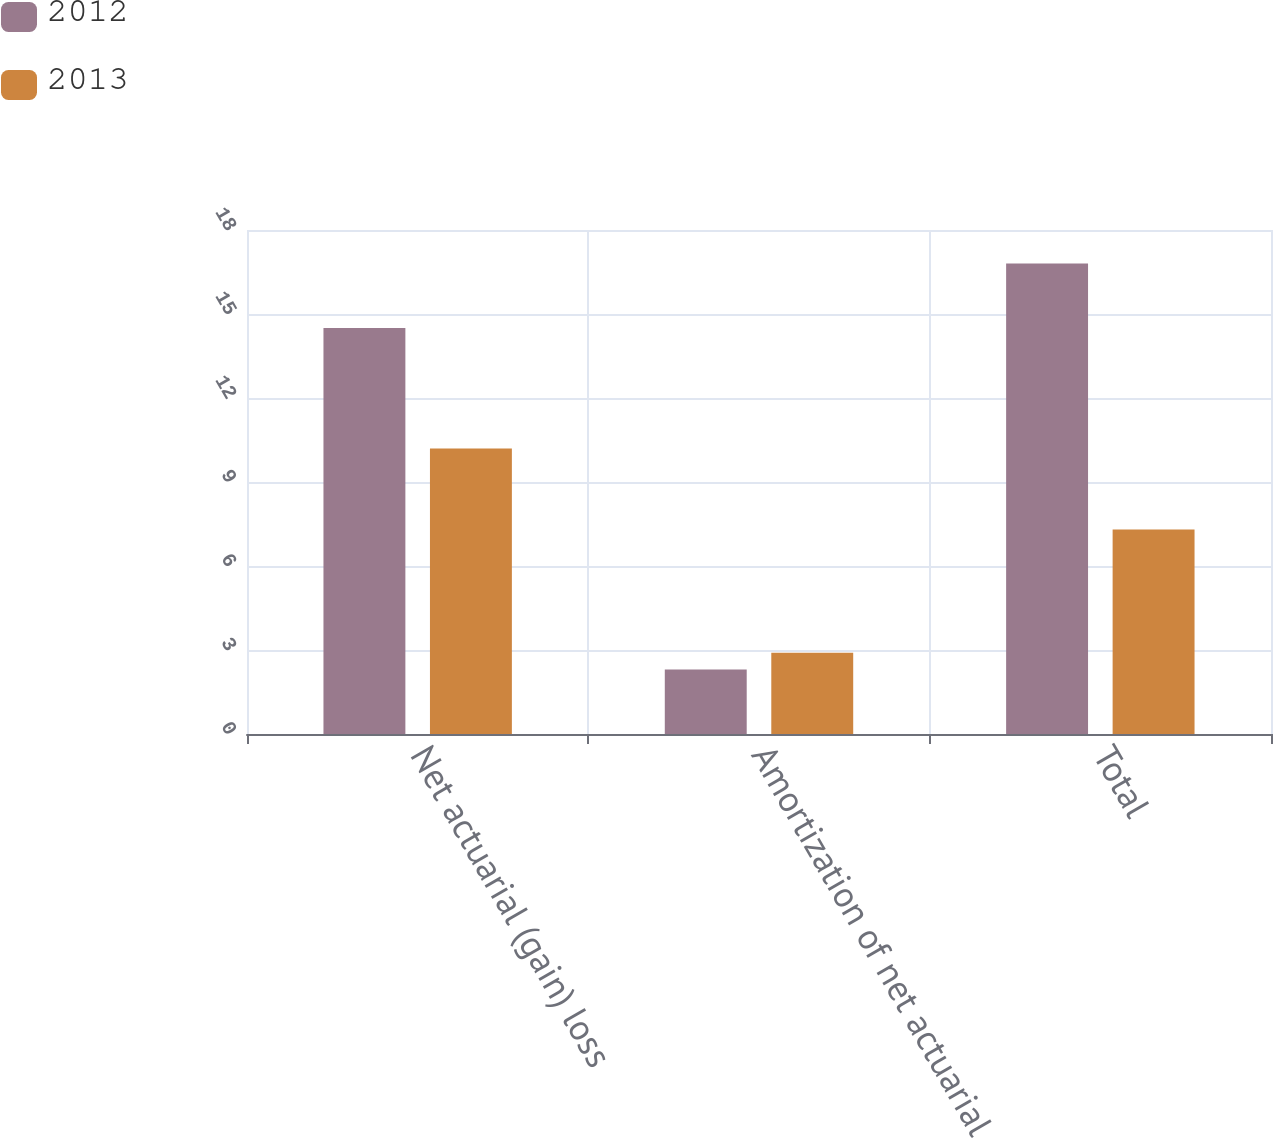Convert chart to OTSL. <chart><loc_0><loc_0><loc_500><loc_500><stacked_bar_chart><ecel><fcel>Net actuarial (gain) loss<fcel>Amortization of net actuarial<fcel>Total<nl><fcel>2012<fcel>14.5<fcel>2.3<fcel>16.8<nl><fcel>2013<fcel>10.2<fcel>2.9<fcel>7.3<nl></chart> 